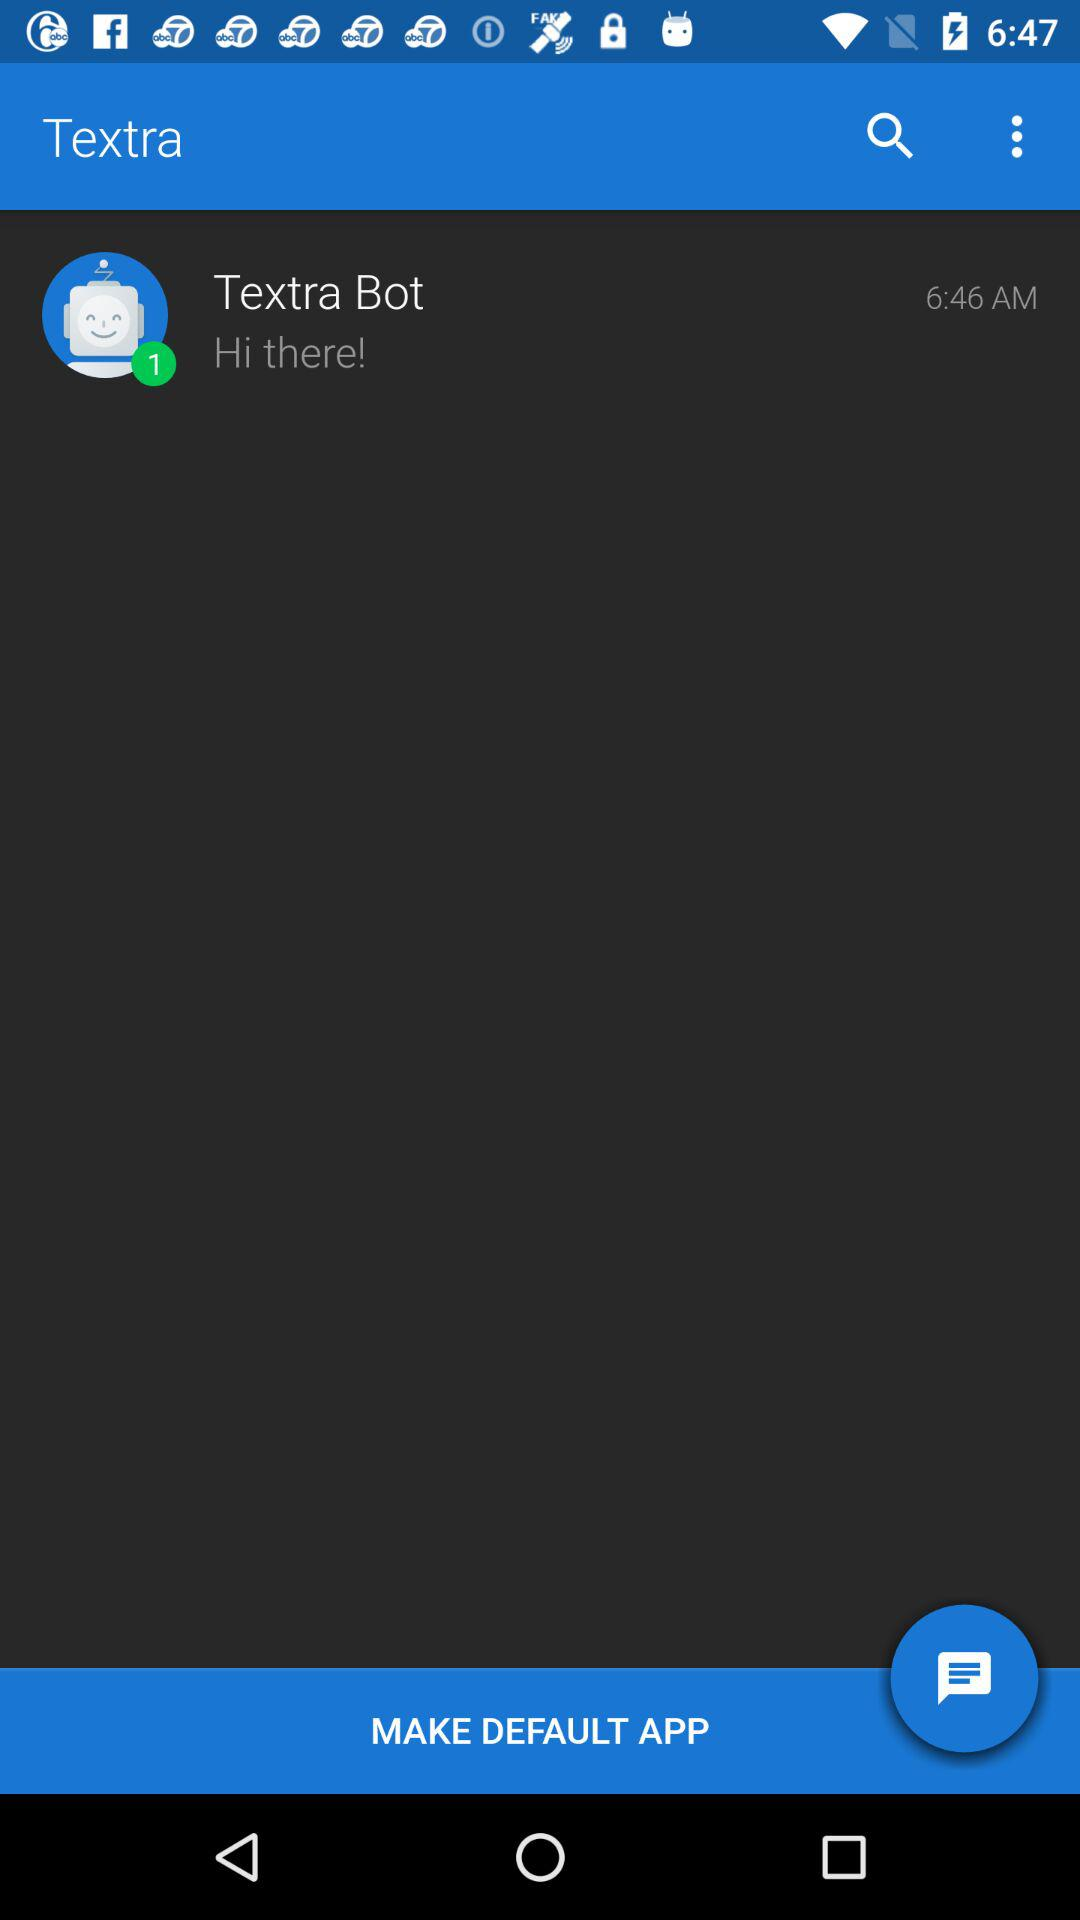At what time was the message from "Textra Bot" received? The message from "Textra Bot" was received at 6:46 a.m. 